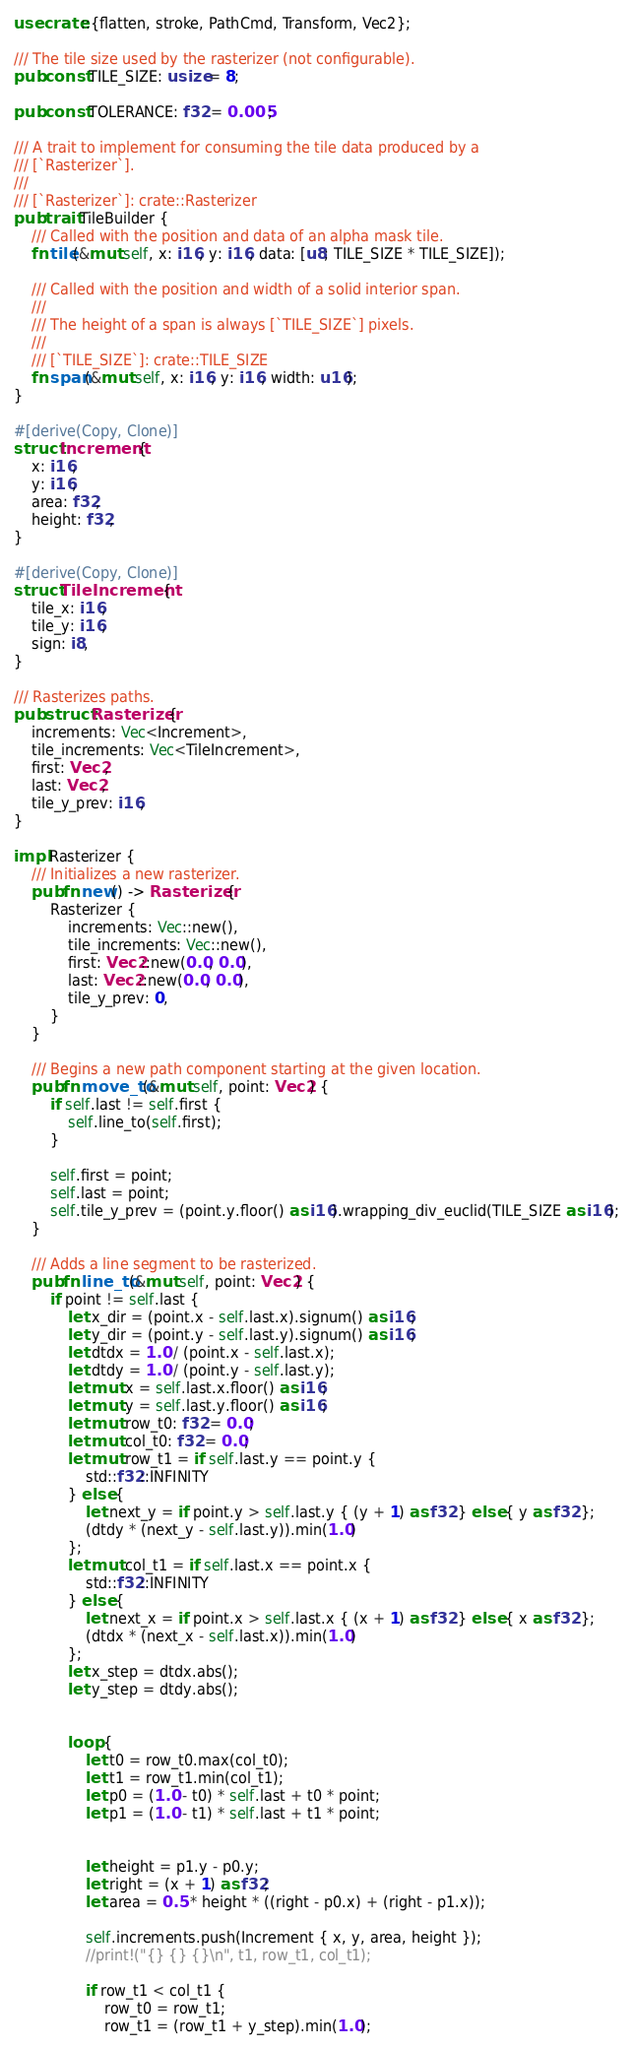<code> <loc_0><loc_0><loc_500><loc_500><_Rust_>use crate::{flatten, stroke, PathCmd, Transform, Vec2};

/// The tile size used by the rasterizer (not configurable).
pub const TILE_SIZE: usize = 8;

pub const TOLERANCE: f32 = 0.005;

/// A trait to implement for consuming the tile data produced by a
/// [`Rasterizer`].
///
/// [`Rasterizer`]: crate::Rasterizer
pub trait TileBuilder {
    /// Called with the position and data of an alpha mask tile.
    fn tile(&mut self, x: i16, y: i16, data: [u8; TILE_SIZE * TILE_SIZE]);

    /// Called with the position and width of a solid interior span.
    ///
    /// The height of a span is always [`TILE_SIZE`] pixels.
    ///
    /// [`TILE_SIZE`]: crate::TILE_SIZE
    fn span(&mut self, x: i16, y: i16, width: u16);
}

#[derive(Copy, Clone)]
struct Increment {
    x: i16,
    y: i16,
    area: f32,
    height: f32,
}

#[derive(Copy, Clone)]
struct TileIncrement {
    tile_x: i16,
    tile_y: i16,
    sign: i8,
}

/// Rasterizes paths.
pub struct Rasterizer {
    increments: Vec<Increment>,
    tile_increments: Vec<TileIncrement>,
    first: Vec2,
    last: Vec2,
    tile_y_prev: i16,
}

impl Rasterizer {
    /// Initializes a new rasterizer.
    pub fn new() -> Rasterizer {
        Rasterizer {
            increments: Vec::new(),
            tile_increments: Vec::new(),
            first: Vec2::new(0.0, 0.0),
            last: Vec2::new(0.0, 0.0),
            tile_y_prev: 0,
        }
    }

    /// Begins a new path component starting at the given location.
    pub fn move_to(&mut self, point: Vec2) {
        if self.last != self.first {
            self.line_to(self.first);
        }

        self.first = point;
        self.last = point;
        self.tile_y_prev = (point.y.floor() as i16).wrapping_div_euclid(TILE_SIZE as i16);
    }

    /// Adds a line segment to be rasterized.
    pub fn line_to(&mut self, point: Vec2) {
        if point != self.last {
            let x_dir = (point.x - self.last.x).signum() as i16;
            let y_dir = (point.y - self.last.y).signum() as i16;
            let dtdx = 1.0 / (point.x - self.last.x);
            let dtdy = 1.0 / (point.y - self.last.y);
            let mut x = self.last.x.floor() as i16;
            let mut y = self.last.y.floor() as i16;
            let mut row_t0: f32 = 0.0;
            let mut col_t0: f32 = 0.0;
            let mut row_t1 = if self.last.y == point.y {
                std::f32::INFINITY
            } else {
                let next_y = if point.y > self.last.y { (y + 1) as f32 } else { y as f32 };
                (dtdy * (next_y - self.last.y)).min(1.0)
            };
            let mut col_t1 = if self.last.x == point.x {
                std::f32::INFINITY
            } else {
                let next_x = if point.x > self.last.x { (x + 1) as f32 } else { x as f32 };
                (dtdx * (next_x - self.last.x)).min(1.0)
            };
            let x_step = dtdx.abs();
            let y_step = dtdy.abs();


            loop {
                let t0 = row_t0.max(col_t0);
                let t1 = row_t1.min(col_t1);
                let p0 = (1.0 - t0) * self.last + t0 * point;
                let p1 = (1.0 - t1) * self.last + t1 * point;


                let height = p1.y - p0.y;
                let right = (x + 1) as f32;
                let area = 0.5 * height * ((right - p0.x) + (right - p1.x));

                self.increments.push(Increment { x, y, area, height });
                //print!("{} {} {}\n", t1, row_t1, col_t1);

                if row_t1 < col_t1 {
                    row_t0 = row_t1;
                    row_t1 = (row_t1 + y_step).min(1.0);</code> 